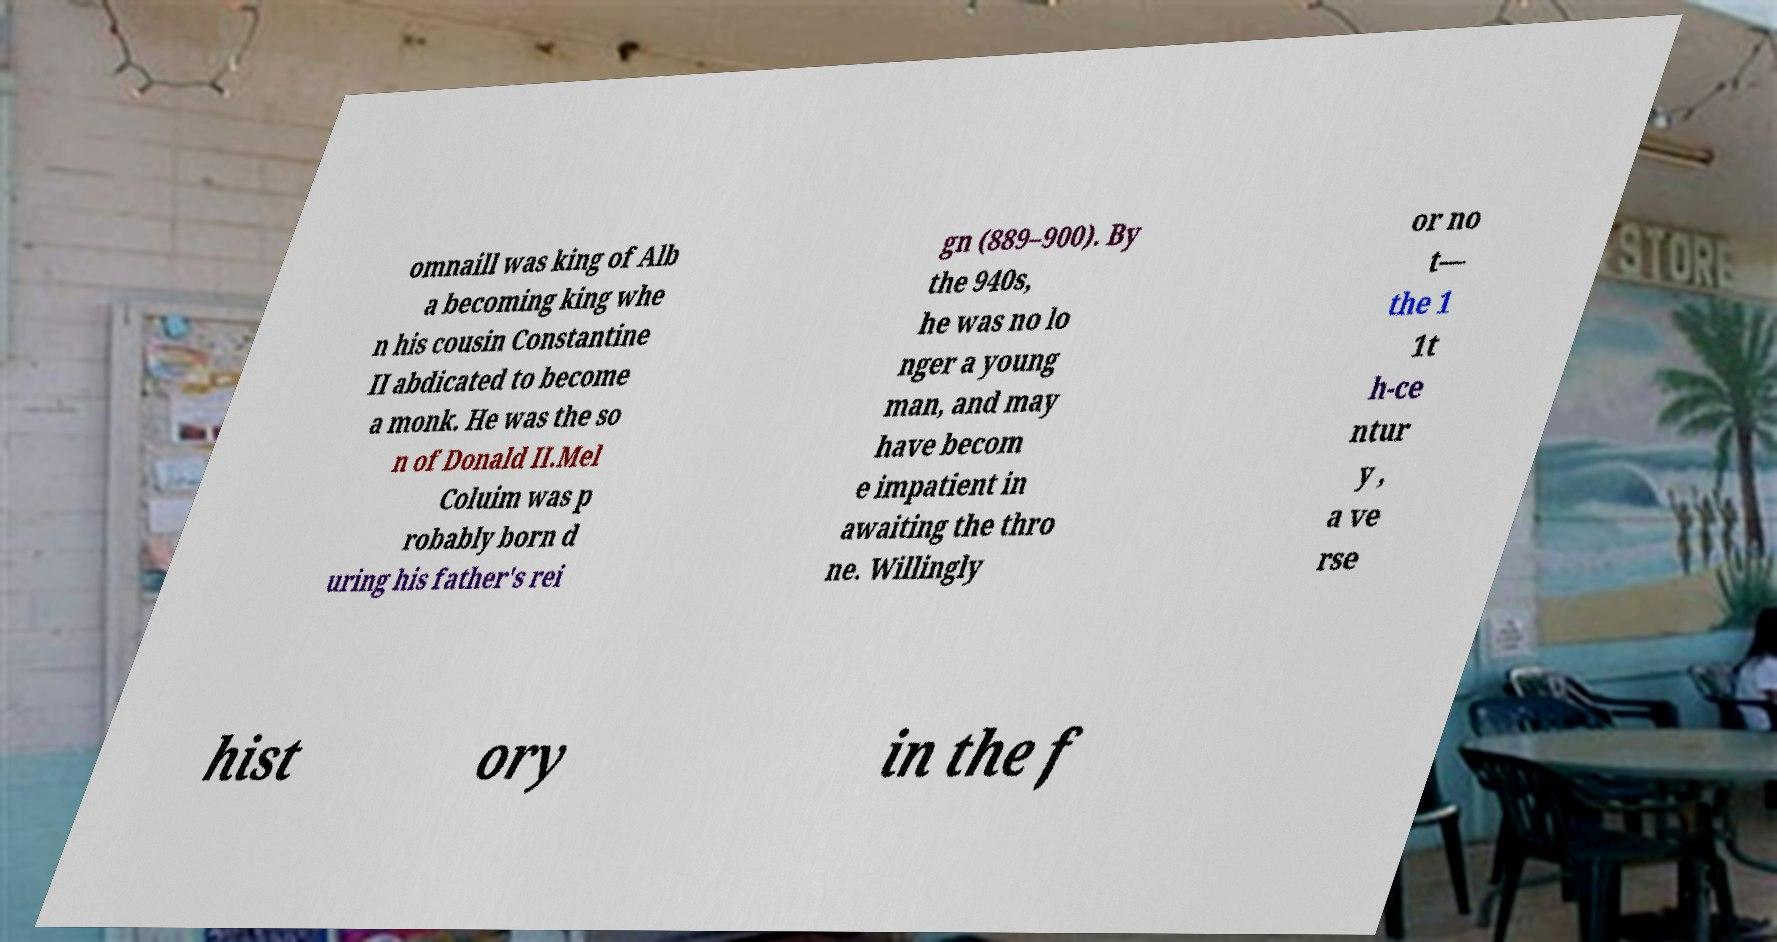Could you assist in decoding the text presented in this image and type it out clearly? omnaill was king of Alb a becoming king whe n his cousin Constantine II abdicated to become a monk. He was the so n of Donald II.Mel Coluim was p robably born d uring his father's rei gn (889–900). By the 940s, he was no lo nger a young man, and may have becom e impatient in awaiting the thro ne. Willingly or no t— the 1 1t h-ce ntur y , a ve rse hist ory in the f 